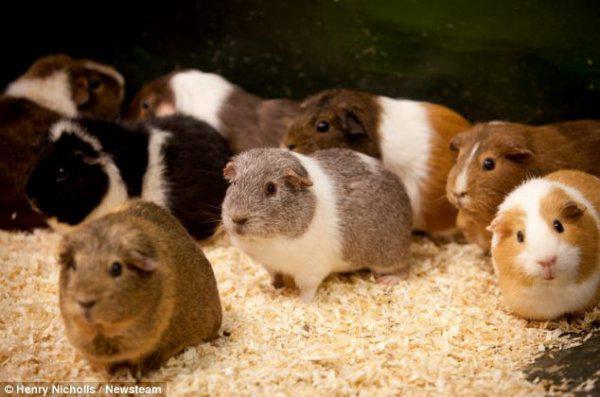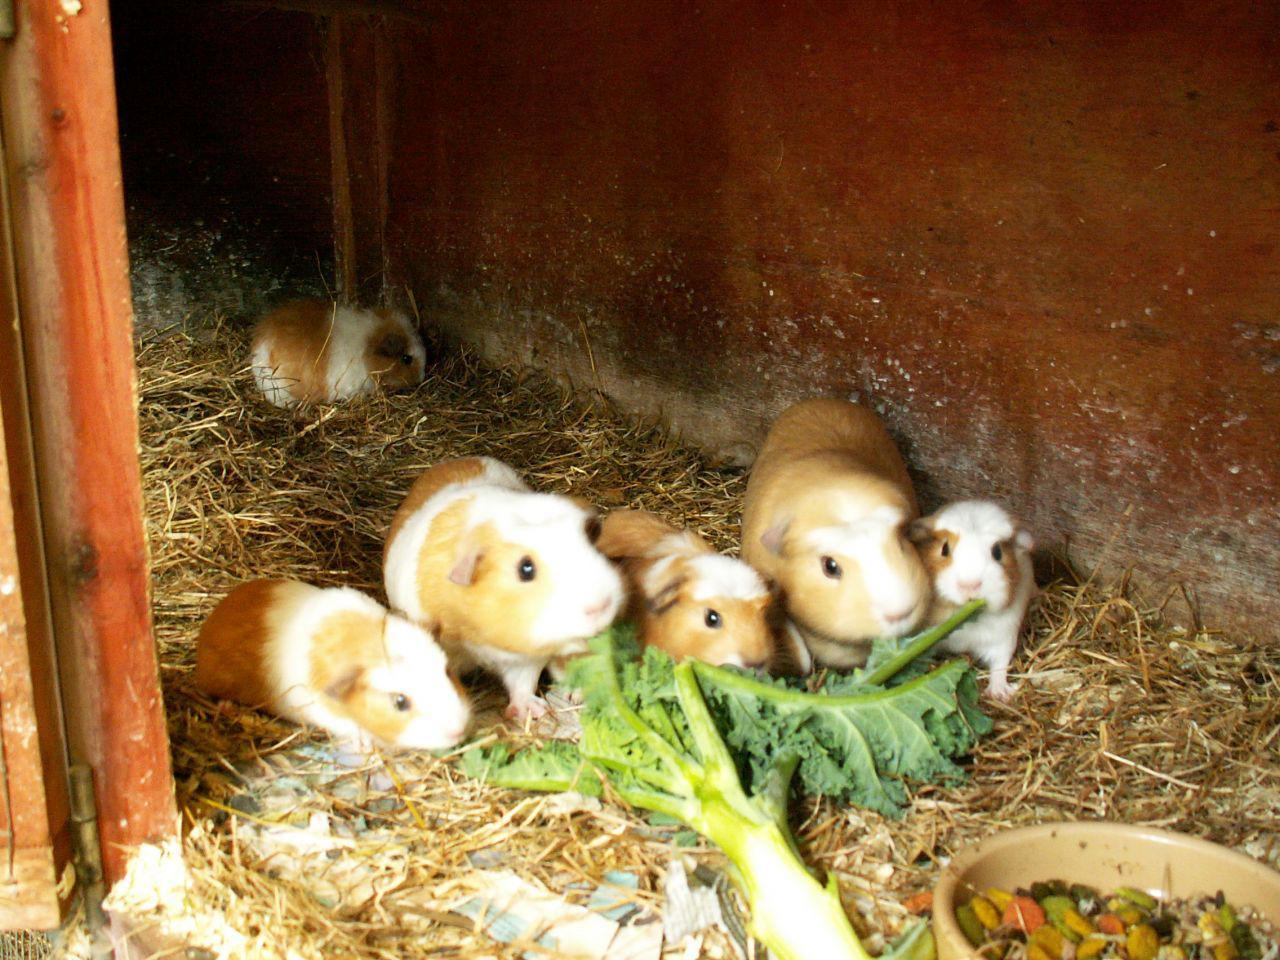The first image is the image on the left, the second image is the image on the right. Considering the images on both sides, is "There is a bowl in the image on the right." valid? Answer yes or no. Yes. 